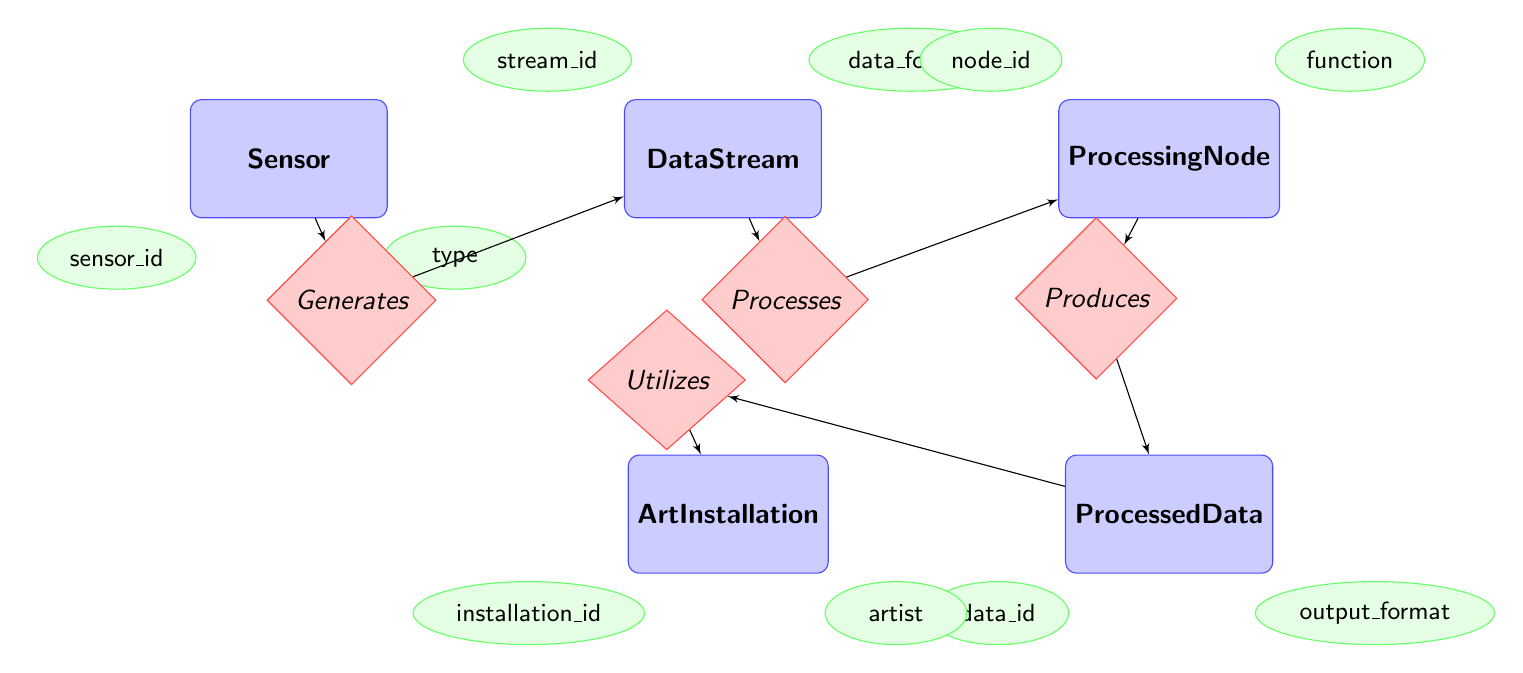What are the attributes of the Sensor entity? The Sensor entity has four attributes: sensor_id, type, location, and status. These attributes are shown in ellipses connected to the Sensor rectangle in the diagram.
Answer: sensor_id, type, location, status How many entities are present in the diagram? The diagram contains five entities: Sensor, DataStream, ProcessingNode, ProcessedData, and ArtInstallation. These are represented by separate rectangles in the diagram.
Answer: five What relationship exists between DataStream and ProcessingNode? The DataStream and ProcessingNode have the relationship named Processes, which is indicated by a diamond connecting the two entities. This relationship is essential for the flow of data in the processing pipeline.
Answer: Processes Which entity generates the DataStream? The Sensor entity generates the DataStream, as indicated by the Generatesthe relationship that connects the Sensor to the DataStream. The direction from Sensor to DataStream shows this flow of information.
Answer: Sensor What is the output format attribute of ProcessedData? The output format attribute of the ProcessedData entity is output_format, as shown in the ellipses linked to the ProcessedData rectangle in the diagram.
Answer: output_format Which entity utilizes the ProcessedData? The ArtInstallation entity utilizes the ProcessedData, as indicated by the Utilizes relationship that connects ProcessedData to ArtInstallation. This shows how the processed data is applied in art installations.
Answer: ArtInstallation What does the ProcessingNode produce? The ProcessingNode produces ProcessedData, as indicated by the Produces relationship connecting ProcessingNode to ProcessedData in the diagram. This signifies that after processing, the data is encapsulated in ProcessedData.
Answer: ProcessedData What is the status attribute associated with ProcessingNode? The ProcessingNode entity includes a status attribute, which is indicated in the list of attributes connected to the ProcessingNode rectangle in the diagram.
Answer: status 